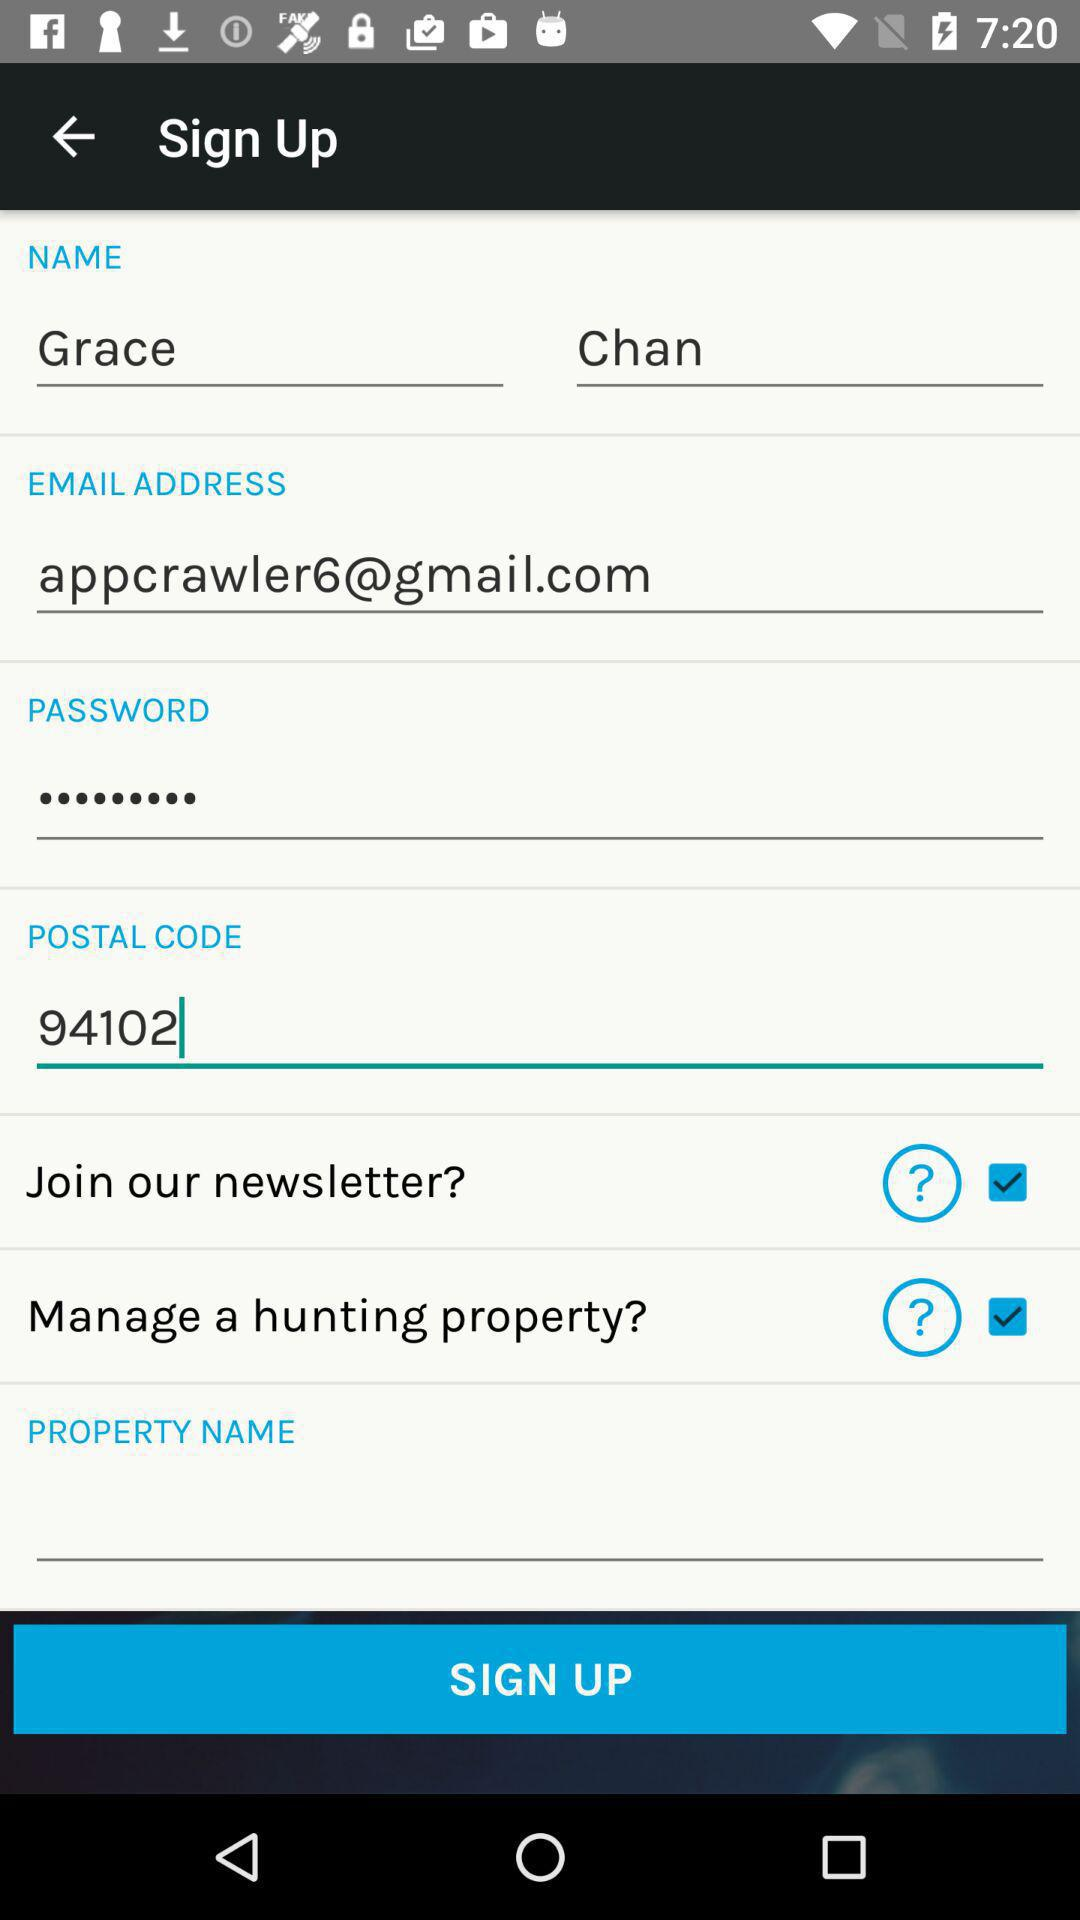What is the postal code? The postal code is 94102. 